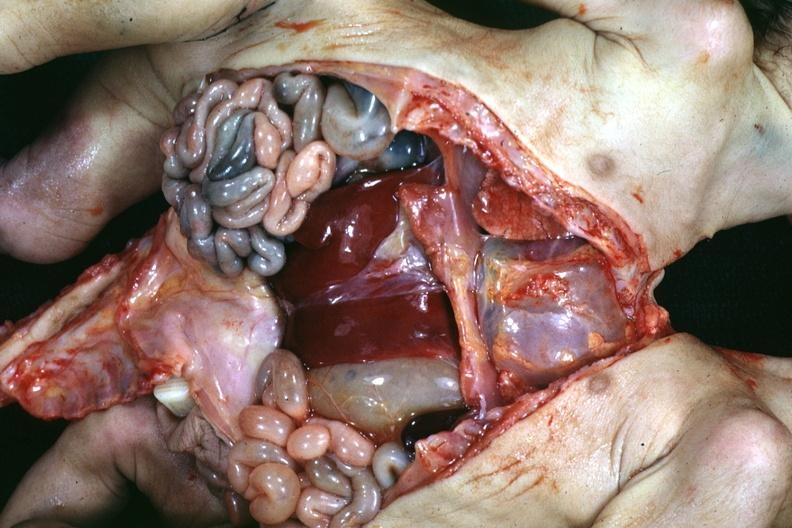how many liver is lower chest and abdomen anterior opened lower chest and abdomen showing apparent two sets intestine with?
Answer the question using a single word or phrase. One 